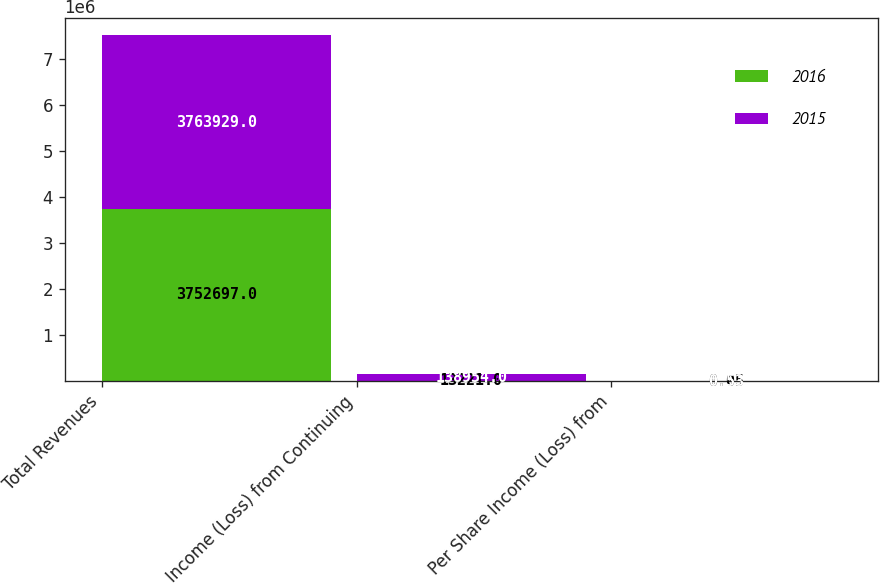Convert chart to OTSL. <chart><loc_0><loc_0><loc_500><loc_500><stacked_bar_chart><ecel><fcel>Total Revenues<fcel>Income (Loss) from Continuing<fcel>Per Share Income (Loss) from<nl><fcel>2016<fcel>3.7527e+06<fcel>13221<fcel>0.05<nl><fcel>2015<fcel>3.76393e+06<fcel>138954<fcel>0.53<nl></chart> 